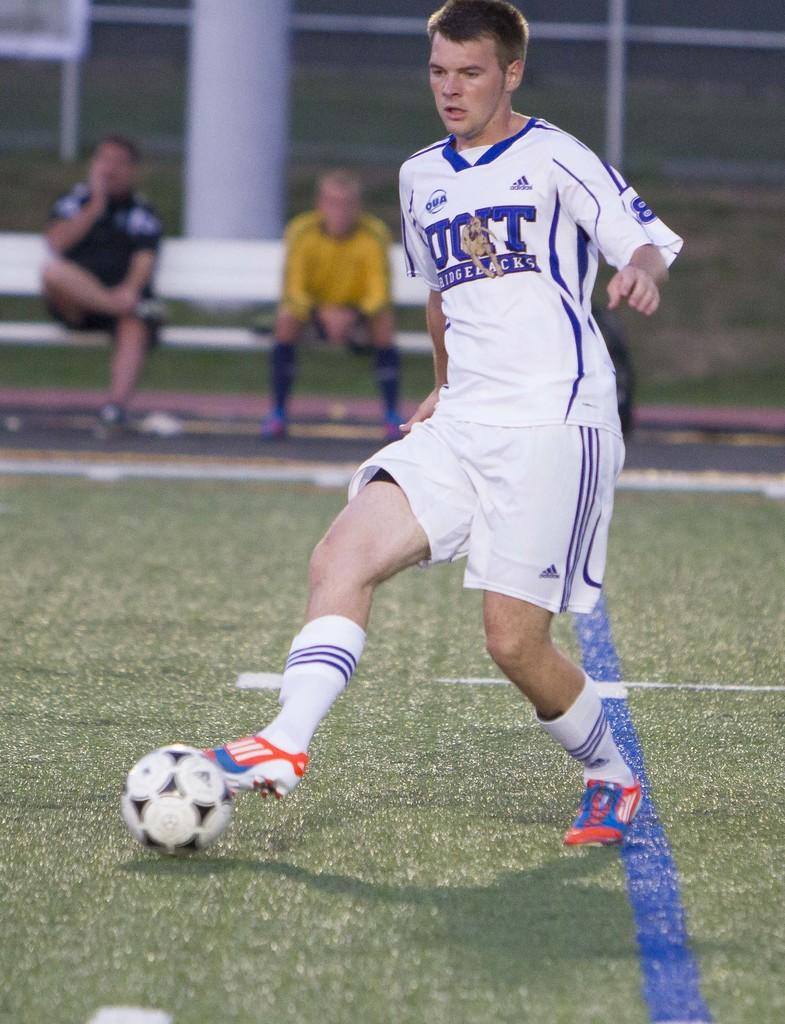Provide a one-sentence caption for the provided image. The Ridgebacks player does some footwork in front of two bored looking players on the bench. 